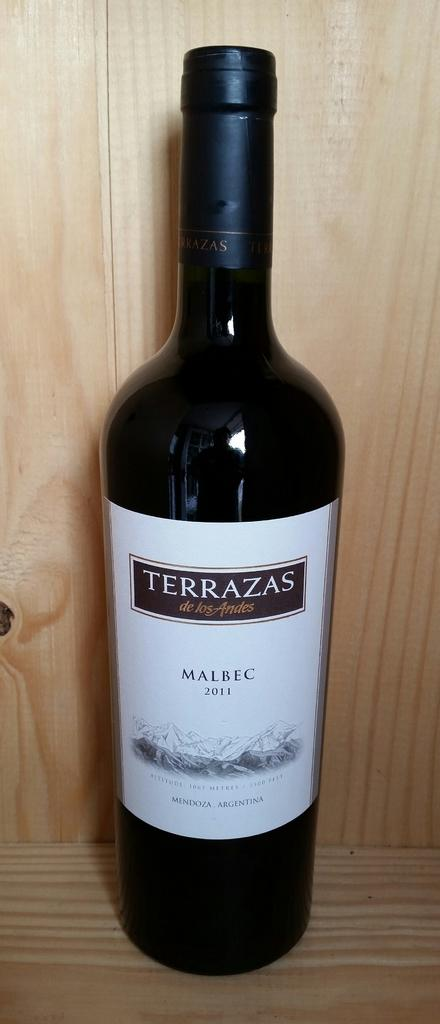Provide a one-sentence caption for the provided image. Terrazas' Malbec  compliments a meal of shrimp and lobster tail. 